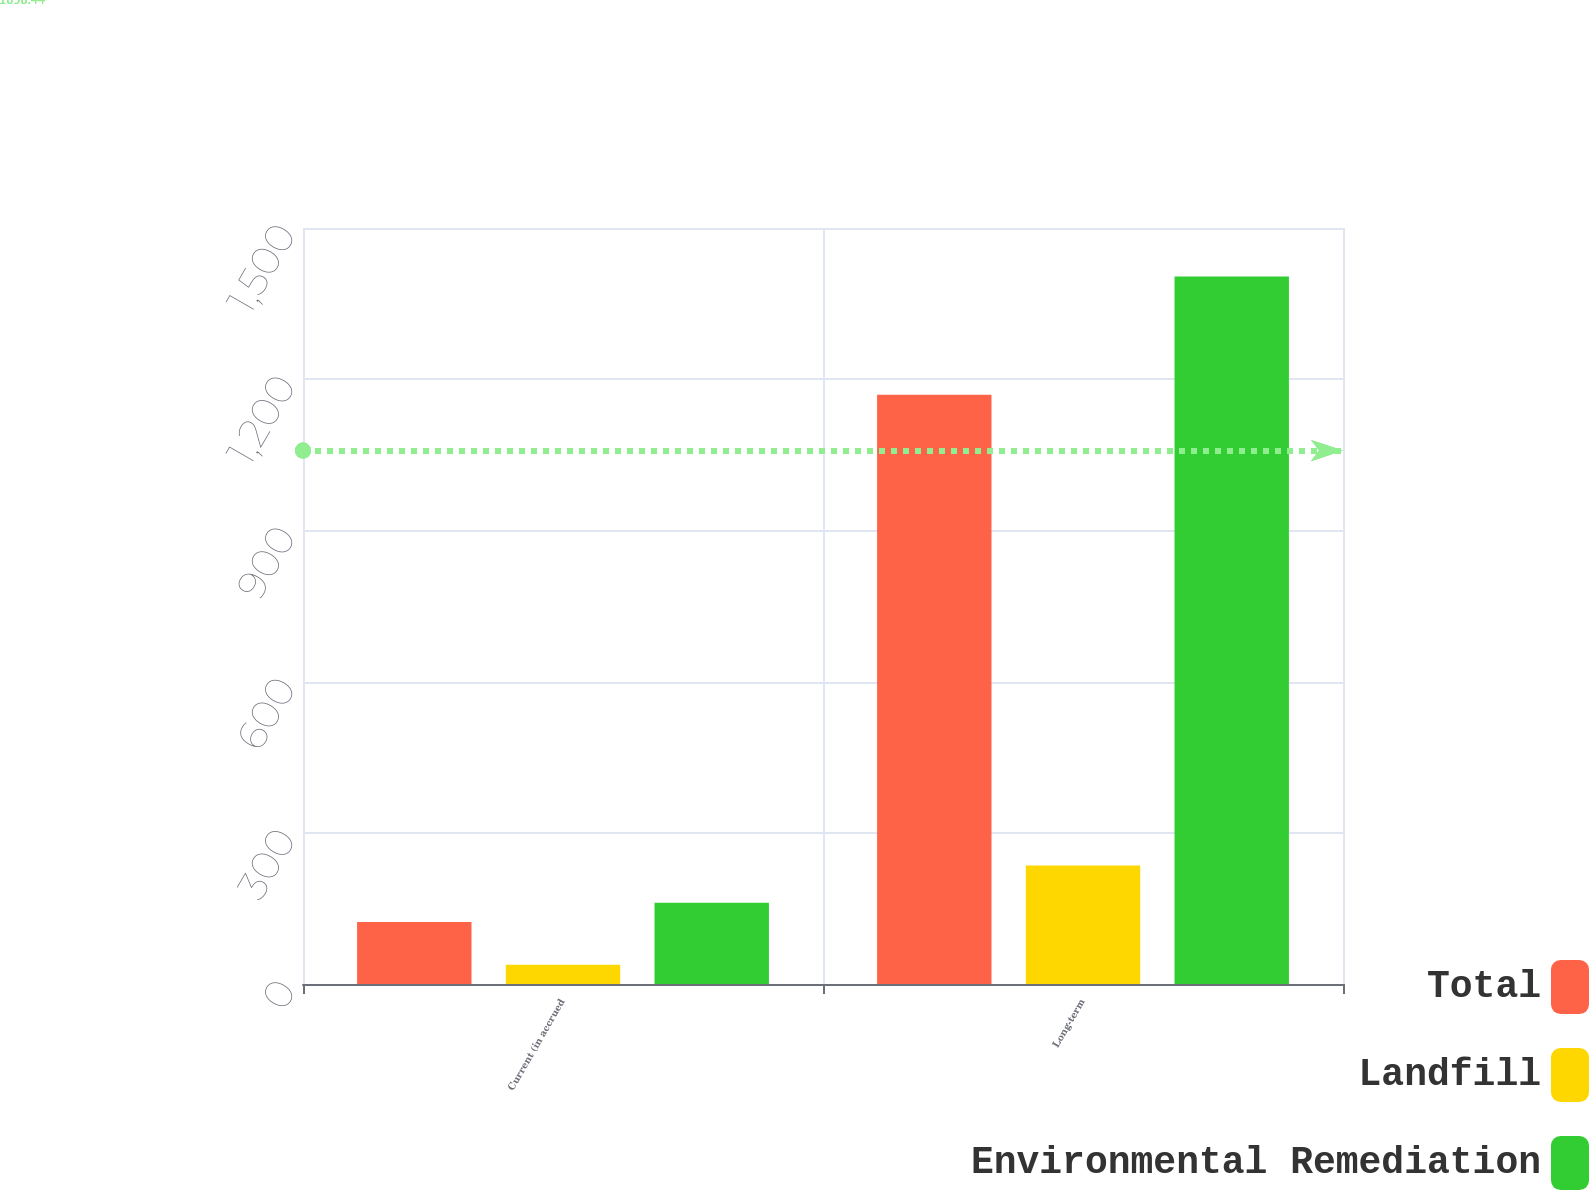<chart> <loc_0><loc_0><loc_500><loc_500><stacked_bar_chart><ecel><fcel>Current (in accrued<fcel>Long-term<nl><fcel>Total<fcel>123<fcel>1169<nl><fcel>Landfill<fcel>38<fcel>235<nl><fcel>Environmental Remediation<fcel>161<fcel>1404<nl></chart> 